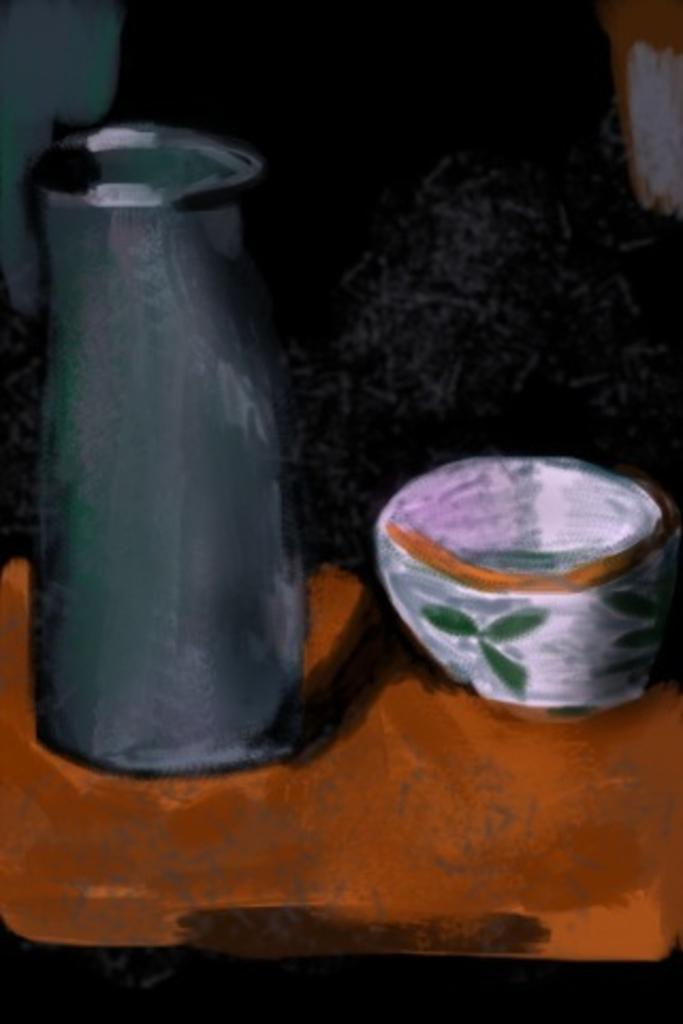What is the main subject of the image? There is a painting in the image. What objects are depicted in the painting? The painting contains a jug and a bowl. What is the color of the object on which the jug and bowl are placed? The objects are placed on a brown color object. How would you describe the background of the painting? The background of the painting is dark in color. Can you tell me the value of the kitty in the painting? There is no kitty present in the painting; it only contains a jug and a bowl. What type of laborer is depicted in the painting? There is no laborer depicted in the painting; it only contains a jug and a bowl. 